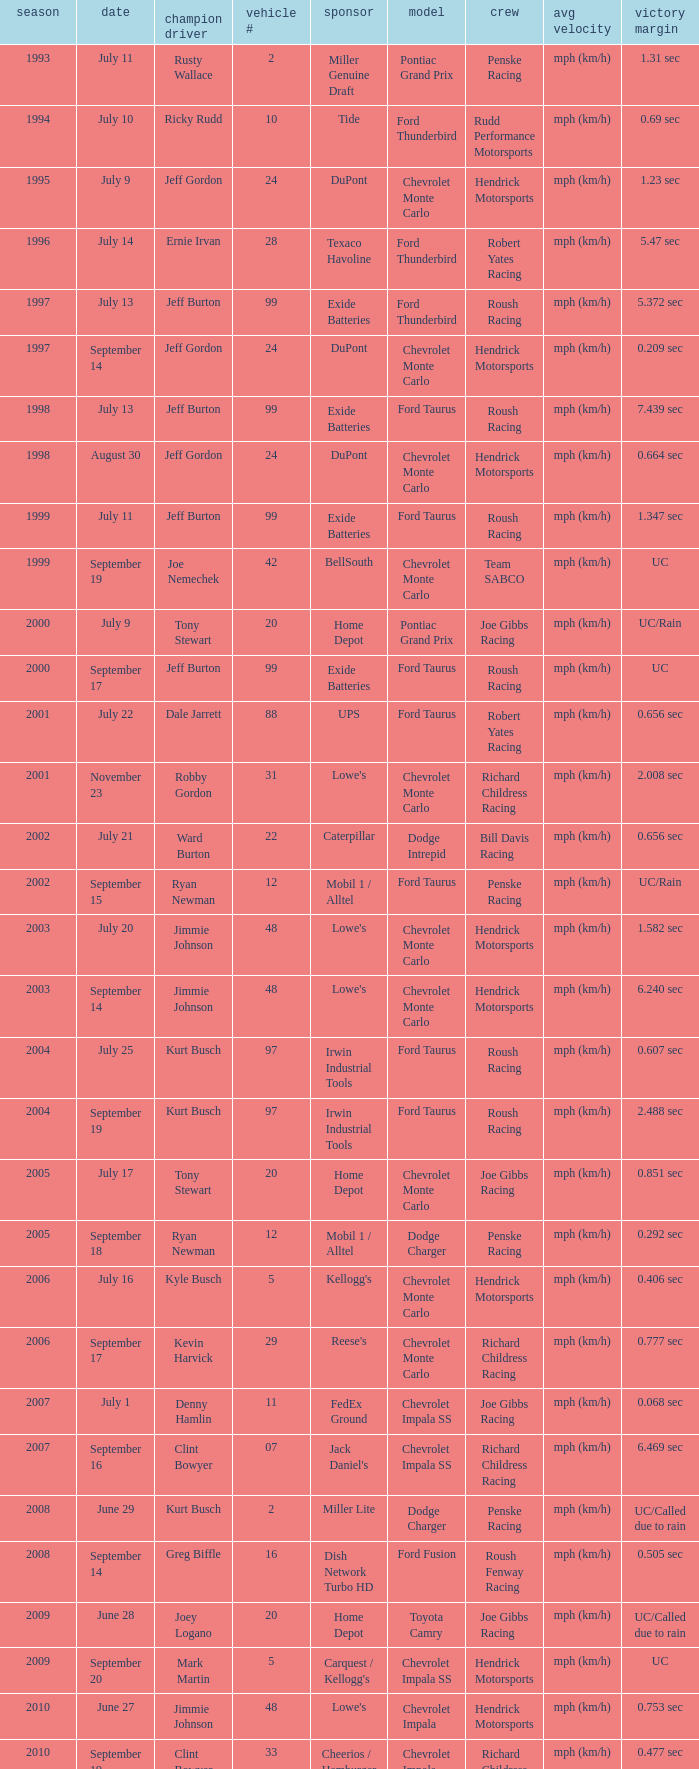What was the average speed of Tony Stewart's winning Chevrolet Impala? Mph (km/h). Could you parse the entire table? {'header': ['season', 'date', 'champion driver', 'vehicle #', 'sponsor', 'model', 'crew', 'avg velocity', 'victory margin'], 'rows': [['1993', 'July 11', 'Rusty Wallace', '2', 'Miller Genuine Draft', 'Pontiac Grand Prix', 'Penske Racing', 'mph (km/h)', '1.31 sec'], ['1994', 'July 10', 'Ricky Rudd', '10', 'Tide', 'Ford Thunderbird', 'Rudd Performance Motorsports', 'mph (km/h)', '0.69 sec'], ['1995', 'July 9', 'Jeff Gordon', '24', 'DuPont', 'Chevrolet Monte Carlo', 'Hendrick Motorsports', 'mph (km/h)', '1.23 sec'], ['1996', 'July 14', 'Ernie Irvan', '28', 'Texaco Havoline', 'Ford Thunderbird', 'Robert Yates Racing', 'mph (km/h)', '5.47 sec'], ['1997', 'July 13', 'Jeff Burton', '99', 'Exide Batteries', 'Ford Thunderbird', 'Roush Racing', 'mph (km/h)', '5.372 sec'], ['1997', 'September 14', 'Jeff Gordon', '24', 'DuPont', 'Chevrolet Monte Carlo', 'Hendrick Motorsports', 'mph (km/h)', '0.209 sec'], ['1998', 'July 13', 'Jeff Burton', '99', 'Exide Batteries', 'Ford Taurus', 'Roush Racing', 'mph (km/h)', '7.439 sec'], ['1998', 'August 30', 'Jeff Gordon', '24', 'DuPont', 'Chevrolet Monte Carlo', 'Hendrick Motorsports', 'mph (km/h)', '0.664 sec'], ['1999', 'July 11', 'Jeff Burton', '99', 'Exide Batteries', 'Ford Taurus', 'Roush Racing', 'mph (km/h)', '1.347 sec'], ['1999', 'September 19', 'Joe Nemechek', '42', 'BellSouth', 'Chevrolet Monte Carlo', 'Team SABCO', 'mph (km/h)', 'UC'], ['2000', 'July 9', 'Tony Stewart', '20', 'Home Depot', 'Pontiac Grand Prix', 'Joe Gibbs Racing', 'mph (km/h)', 'UC/Rain'], ['2000', 'September 17', 'Jeff Burton', '99', 'Exide Batteries', 'Ford Taurus', 'Roush Racing', 'mph (km/h)', 'UC'], ['2001', 'July 22', 'Dale Jarrett', '88', 'UPS', 'Ford Taurus', 'Robert Yates Racing', 'mph (km/h)', '0.656 sec'], ['2001', 'November 23', 'Robby Gordon', '31', "Lowe's", 'Chevrolet Monte Carlo', 'Richard Childress Racing', 'mph (km/h)', '2.008 sec'], ['2002', 'July 21', 'Ward Burton', '22', 'Caterpillar', 'Dodge Intrepid', 'Bill Davis Racing', 'mph (km/h)', '0.656 sec'], ['2002', 'September 15', 'Ryan Newman', '12', 'Mobil 1 / Alltel', 'Ford Taurus', 'Penske Racing', 'mph (km/h)', 'UC/Rain'], ['2003', 'July 20', 'Jimmie Johnson', '48', "Lowe's", 'Chevrolet Monte Carlo', 'Hendrick Motorsports', 'mph (km/h)', '1.582 sec'], ['2003', 'September 14', 'Jimmie Johnson', '48', "Lowe's", 'Chevrolet Monte Carlo', 'Hendrick Motorsports', 'mph (km/h)', '6.240 sec'], ['2004', 'July 25', 'Kurt Busch', '97', 'Irwin Industrial Tools', 'Ford Taurus', 'Roush Racing', 'mph (km/h)', '0.607 sec'], ['2004', 'September 19', 'Kurt Busch', '97', 'Irwin Industrial Tools', 'Ford Taurus', 'Roush Racing', 'mph (km/h)', '2.488 sec'], ['2005', 'July 17', 'Tony Stewart', '20', 'Home Depot', 'Chevrolet Monte Carlo', 'Joe Gibbs Racing', 'mph (km/h)', '0.851 sec'], ['2005', 'September 18', 'Ryan Newman', '12', 'Mobil 1 / Alltel', 'Dodge Charger', 'Penske Racing', 'mph (km/h)', '0.292 sec'], ['2006', 'July 16', 'Kyle Busch', '5', "Kellogg's", 'Chevrolet Monte Carlo', 'Hendrick Motorsports', 'mph (km/h)', '0.406 sec'], ['2006', 'September 17', 'Kevin Harvick', '29', "Reese's", 'Chevrolet Monte Carlo', 'Richard Childress Racing', 'mph (km/h)', '0.777 sec'], ['2007', 'July 1', 'Denny Hamlin', '11', 'FedEx Ground', 'Chevrolet Impala SS', 'Joe Gibbs Racing', 'mph (km/h)', '0.068 sec'], ['2007', 'September 16', 'Clint Bowyer', '07', "Jack Daniel's", 'Chevrolet Impala SS', 'Richard Childress Racing', 'mph (km/h)', '6.469 sec'], ['2008', 'June 29', 'Kurt Busch', '2', 'Miller Lite', 'Dodge Charger', 'Penske Racing', 'mph (km/h)', 'UC/Called due to rain'], ['2008', 'September 14', 'Greg Biffle', '16', 'Dish Network Turbo HD', 'Ford Fusion', 'Roush Fenway Racing', 'mph (km/h)', '0.505 sec'], ['2009', 'June 28', 'Joey Logano', '20', 'Home Depot', 'Toyota Camry', 'Joe Gibbs Racing', 'mph (km/h)', 'UC/Called due to rain'], ['2009', 'September 20', 'Mark Martin', '5', "Carquest / Kellogg's", 'Chevrolet Impala SS', 'Hendrick Motorsports', 'mph (km/h)', 'UC'], ['2010', 'June 27', 'Jimmie Johnson', '48', "Lowe's", 'Chevrolet Impala', 'Hendrick Motorsports', 'mph (km/h)', '0.753 sec'], ['2010', 'September 19', 'Clint Bowyer', '33', 'Cheerios / Hamburger Helper', 'Chevrolet Impala', 'Richard Childress Racing', 'mph (km/h)', '0.477 sec'], ['2011', 'July 17', 'Ryan Newman', '39', 'U.S. Army', 'Chevrolet Impala', 'Stewart-Haas Racing', 'mph (km/h)', '0.773 sec'], ['2011', 'September 25', 'Tony Stewart', '14', 'Mobil 1 / Office Depot', 'Chevrolet Impala', 'Stewart-Haas Racing', 'mph (km/h)', '7.225 sec'], ['2012', 'July 15', 'Kasey Kahne', '5', 'Farmers Insurance', 'Chevrolet Impala', 'Hendrick Motorsports', 'mph (km/h)', '2.738 sec'], ['2012', 'September 23', 'Denny Hamlin', '11', 'FedEx Freight', 'Toyota Camry', 'Joe Gibbs Racing', 'mph (km/h)', '2.675 sec'], ['2013', 'July 14', 'Brian Vickers', '55', "Aaron's", 'Toyota Camry', 'Michael Waltrip Racing', 'mph (km/h)', '.582 sec'], ['2013', 'September 22', 'Matt Kenseth', '20', 'Husky Tools', 'Toyota Camry', 'Joe Gibbs Racing', 'mph (km/h)', '.533 sec']]} 